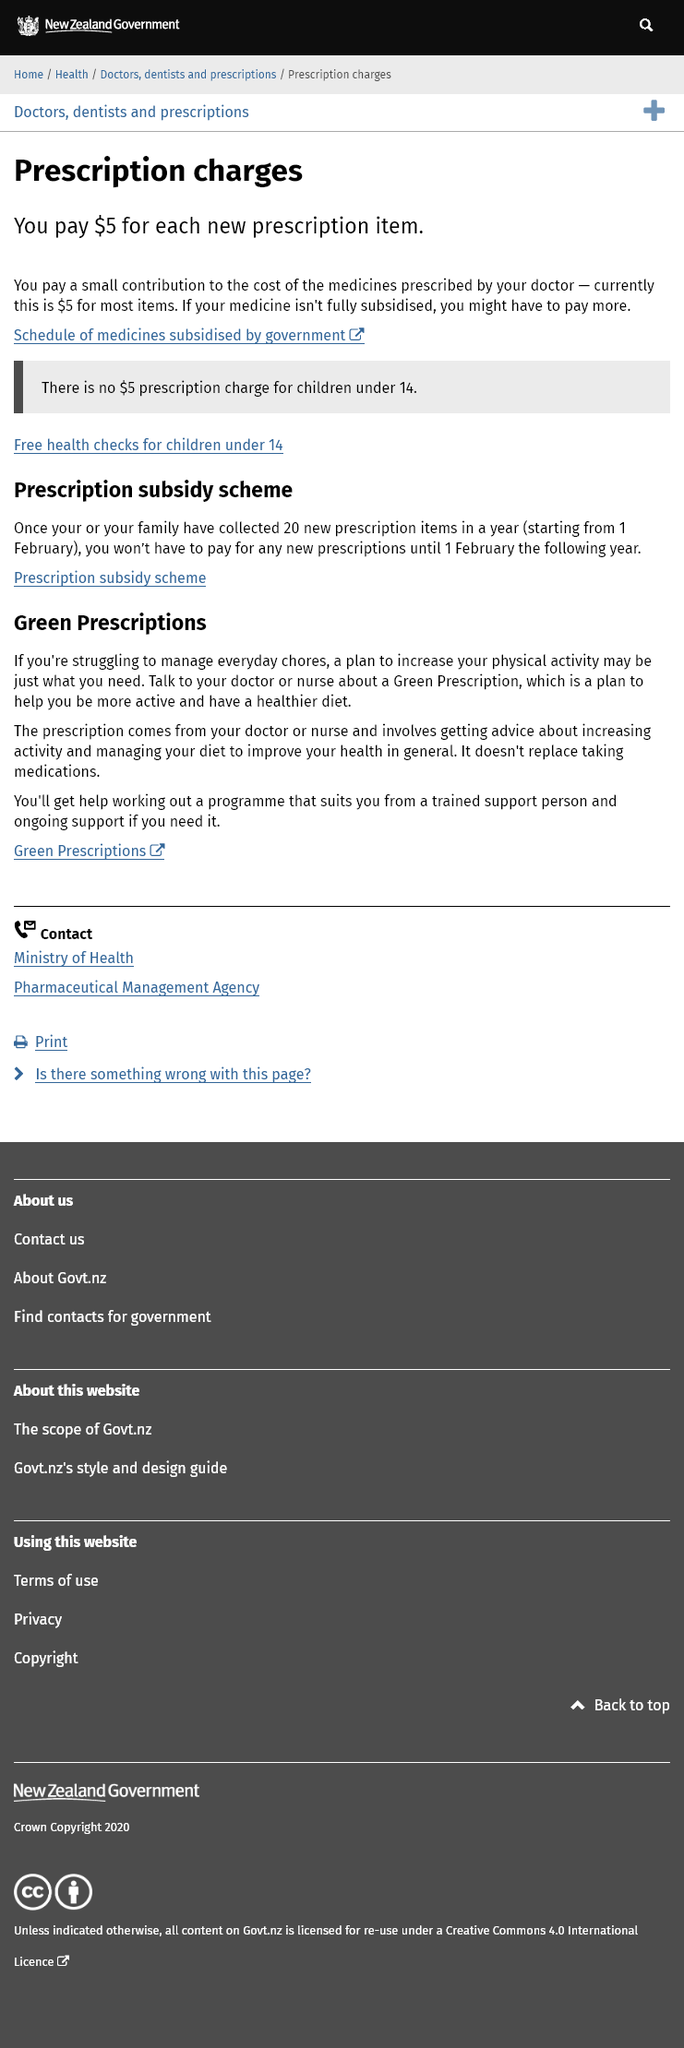Mention a couple of crucial points in this snapshot. If a medicine is not fully subsidised, the prescription charge may increase. The cost for each prescription item is $5 if you are 14 years old or older. Each prescription is $5 for individuals aged 13 or older. Under the age of 14, each prescription item is free of charge, and there is no prescription fee required. 